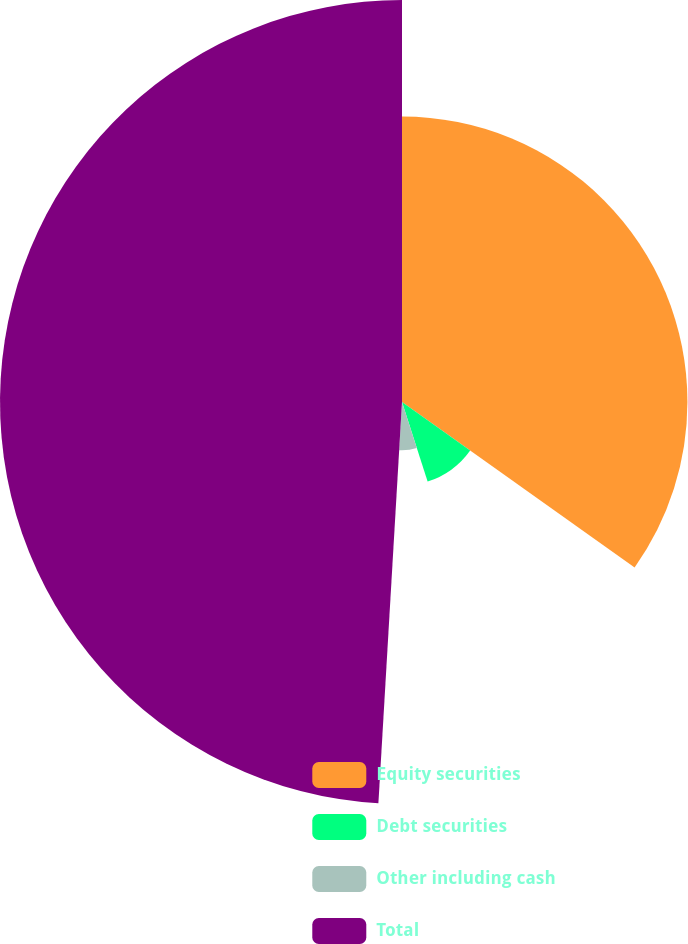Convert chart to OTSL. <chart><loc_0><loc_0><loc_500><loc_500><pie_chart><fcel>Equity securities<fcel>Debt securities<fcel>Other including cash<fcel>Total<nl><fcel>34.84%<fcel>10.21%<fcel>5.89%<fcel>49.07%<nl></chart> 